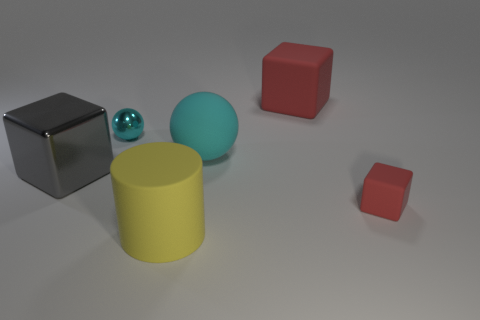Does the tiny thing on the left side of the yellow rubber thing have the same color as the small object that is right of the cylinder?
Your answer should be very brief. No. Is there a big red metal cylinder?
Ensure brevity in your answer.  No. Is there a tiny ball made of the same material as the big cylinder?
Your response must be concise. No. The large cylinder has what color?
Offer a terse response. Yellow. What shape is the big thing that is the same color as the shiny sphere?
Keep it short and to the point. Sphere. The rubber cube that is the same size as the cyan matte ball is what color?
Keep it short and to the point. Red. What number of matte things are tiny green things or yellow things?
Keep it short and to the point. 1. How many large objects are to the right of the small shiny thing and in front of the tiny cyan object?
Ensure brevity in your answer.  2. Are there any other things that have the same shape as the yellow object?
Your answer should be very brief. No. How many other things are there of the same size as the cyan rubber sphere?
Provide a succinct answer. 3. 